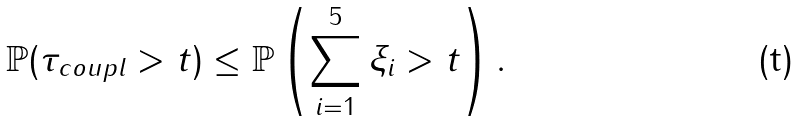<formula> <loc_0><loc_0><loc_500><loc_500>\mathbb { P } ( \tau _ { c o u p l } > t ) \leq \mathbb { P } \left ( \sum _ { i = 1 } ^ { 5 } \xi _ { i } > t \right ) .</formula> 